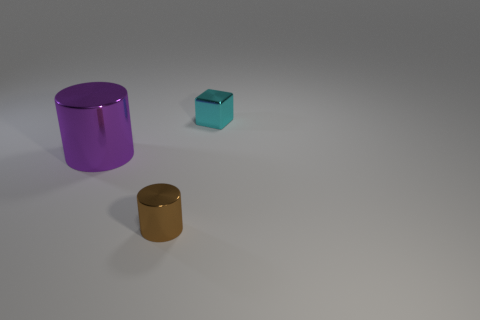Add 2 large blue rubber objects. How many objects exist? 5 Subtract all cylinders. How many objects are left? 1 Subtract 0 brown spheres. How many objects are left? 3 Subtract all tiny metallic blocks. Subtract all cubes. How many objects are left? 1 Add 2 small cyan shiny objects. How many small cyan shiny objects are left? 3 Add 3 large cylinders. How many large cylinders exist? 4 